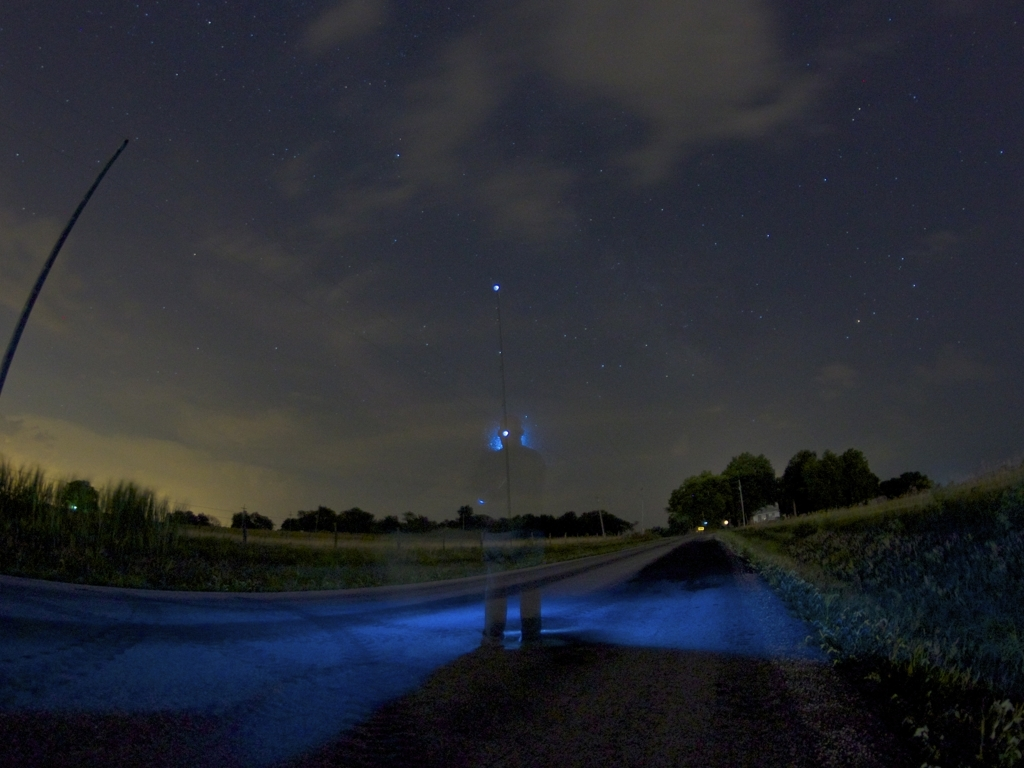Can you explain the lighting in this image? The illumination in this image seems to be natural and ambient, most likely from the moon or distant artificial light sources. There's a blue glow that appears to be from a handheld light or smartphone, which highlights the person and creates the ghostly effect. How would a photographer achieve this effect? To achieve this effect, a photographer would use a slow shutter speed while the subject moves or turns off a light source during the exposure. It requires careful planning and control of the available light, as well as stabilization of the camera to avoid unintentional blur in the static elements of the composition. 